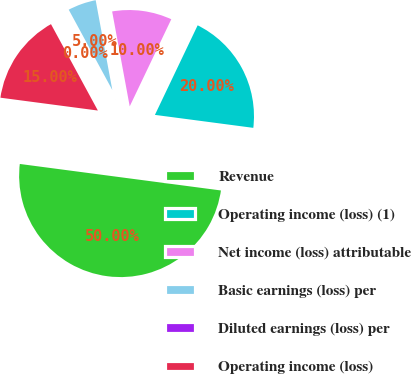<chart> <loc_0><loc_0><loc_500><loc_500><pie_chart><fcel>Revenue<fcel>Operating income (loss) (1)<fcel>Net income (loss) attributable<fcel>Basic earnings (loss) per<fcel>Diluted earnings (loss) per<fcel>Operating income (loss)<nl><fcel>50.0%<fcel>20.0%<fcel>10.0%<fcel>5.0%<fcel>0.0%<fcel>15.0%<nl></chart> 